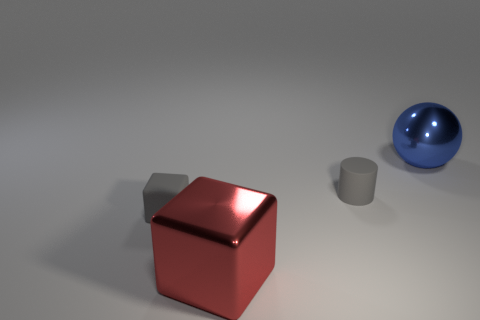Add 2 green rubber blocks. How many objects exist? 6 Subtract all cylinders. How many objects are left? 3 Add 4 big red blocks. How many big red blocks exist? 5 Subtract 0 yellow balls. How many objects are left? 4 Subtract all small yellow matte things. Subtract all small cubes. How many objects are left? 3 Add 2 big objects. How many big objects are left? 4 